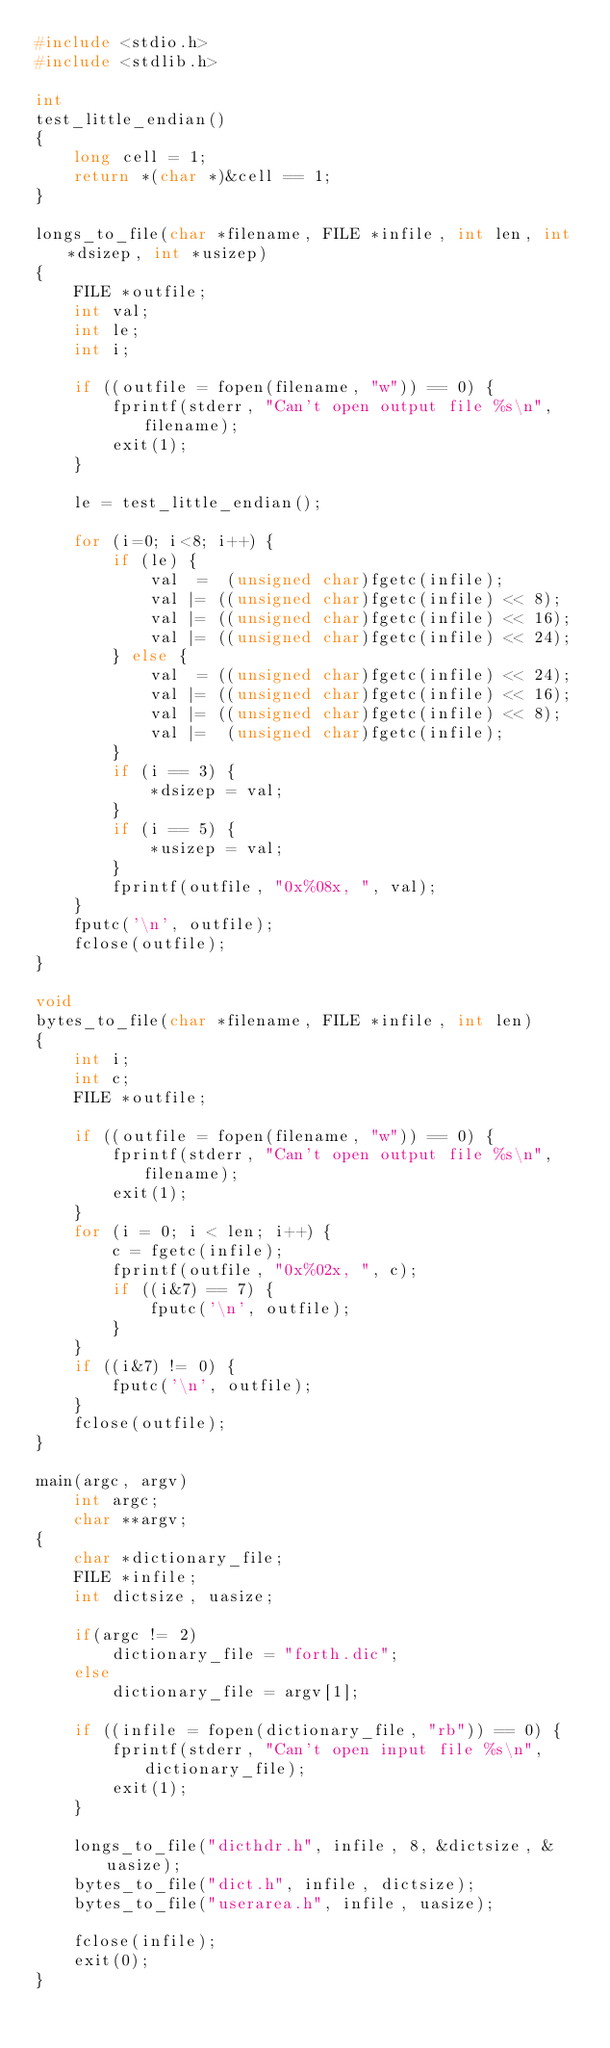<code> <loc_0><loc_0><loc_500><loc_500><_C_>#include <stdio.h>
#include <stdlib.h>

int
test_little_endian()
{
    long cell = 1;
    return *(char *)&cell == 1;
}

longs_to_file(char *filename, FILE *infile, int len, int *dsizep, int *usizep)
{
    FILE *outfile;
    int val;
    int le;
    int i;

    if ((outfile = fopen(filename, "w")) == 0) {
        fprintf(stderr, "Can't open output file %s\n", filename);
        exit(1);
    }

    le = test_little_endian();

    for (i=0; i<8; i++) {
        if (le) {
            val  =  (unsigned char)fgetc(infile);
            val |= ((unsigned char)fgetc(infile) << 8);
            val |= ((unsigned char)fgetc(infile) << 16);
            val |= ((unsigned char)fgetc(infile) << 24);
        } else {
            val  = ((unsigned char)fgetc(infile) << 24);
            val |= ((unsigned char)fgetc(infile) << 16);
            val |= ((unsigned char)fgetc(infile) << 8);
            val |=  (unsigned char)fgetc(infile);
        }
        if (i == 3) {
            *dsizep = val;
        }
        if (i == 5) {
            *usizep = val;
        }
        fprintf(outfile, "0x%08x, ", val);
    }
    fputc('\n', outfile);
    fclose(outfile);
}

void
bytes_to_file(char *filename, FILE *infile, int len)
{
    int i;
    int c;
    FILE *outfile;

    if ((outfile = fopen(filename, "w")) == 0) {
        fprintf(stderr, "Can't open output file %s\n", filename);
        exit(1);
    }
    for (i = 0; i < len; i++) {
        c = fgetc(infile);
        fprintf(outfile, "0x%02x, ", c);
        if ((i&7) == 7) {
            fputc('\n', outfile);
        }
    }
    if ((i&7) != 0) {
        fputc('\n', outfile);
    }
    fclose(outfile);
}

main(argc, argv)
    int argc;
    char **argv;
{
    char *dictionary_file;
    FILE *infile;
    int dictsize, uasize;

    if(argc != 2)
        dictionary_file = "forth.dic";
    else
        dictionary_file = argv[1];

    if ((infile = fopen(dictionary_file, "rb")) == 0) {
        fprintf(stderr, "Can't open input file %s\n", dictionary_file);
        exit(1);
    }

    longs_to_file("dicthdr.h", infile, 8, &dictsize, &uasize);
    bytes_to_file("dict.h", infile, dictsize);
    bytes_to_file("userarea.h", infile, uasize);

    fclose(infile);
    exit(0);
}
</code> 